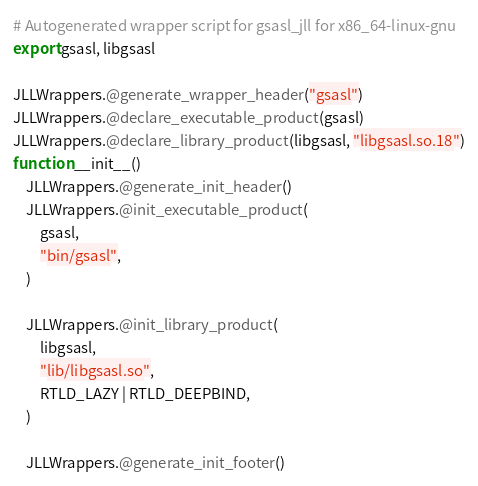Convert code to text. <code><loc_0><loc_0><loc_500><loc_500><_Julia_># Autogenerated wrapper script for gsasl_jll for x86_64-linux-gnu
export gsasl, libgsasl

JLLWrappers.@generate_wrapper_header("gsasl")
JLLWrappers.@declare_executable_product(gsasl)
JLLWrappers.@declare_library_product(libgsasl, "libgsasl.so.18")
function __init__()
    JLLWrappers.@generate_init_header()
    JLLWrappers.@init_executable_product(
        gsasl,
        "bin/gsasl",
    )

    JLLWrappers.@init_library_product(
        libgsasl,
        "lib/libgsasl.so",
        RTLD_LAZY | RTLD_DEEPBIND,
    )

    JLLWrappers.@generate_init_footer()</code> 